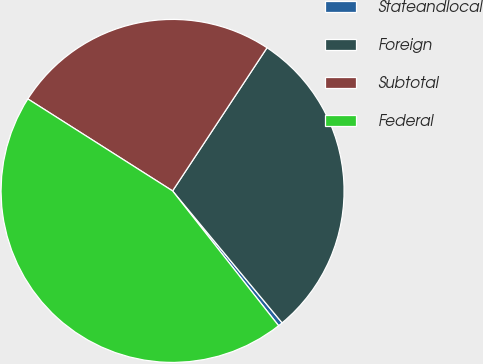Convert chart. <chart><loc_0><loc_0><loc_500><loc_500><pie_chart><fcel>Stateandlocal<fcel>Foreign<fcel>Subtotal<fcel>Federal<nl><fcel>0.42%<fcel>29.69%<fcel>25.27%<fcel>44.62%<nl></chart> 